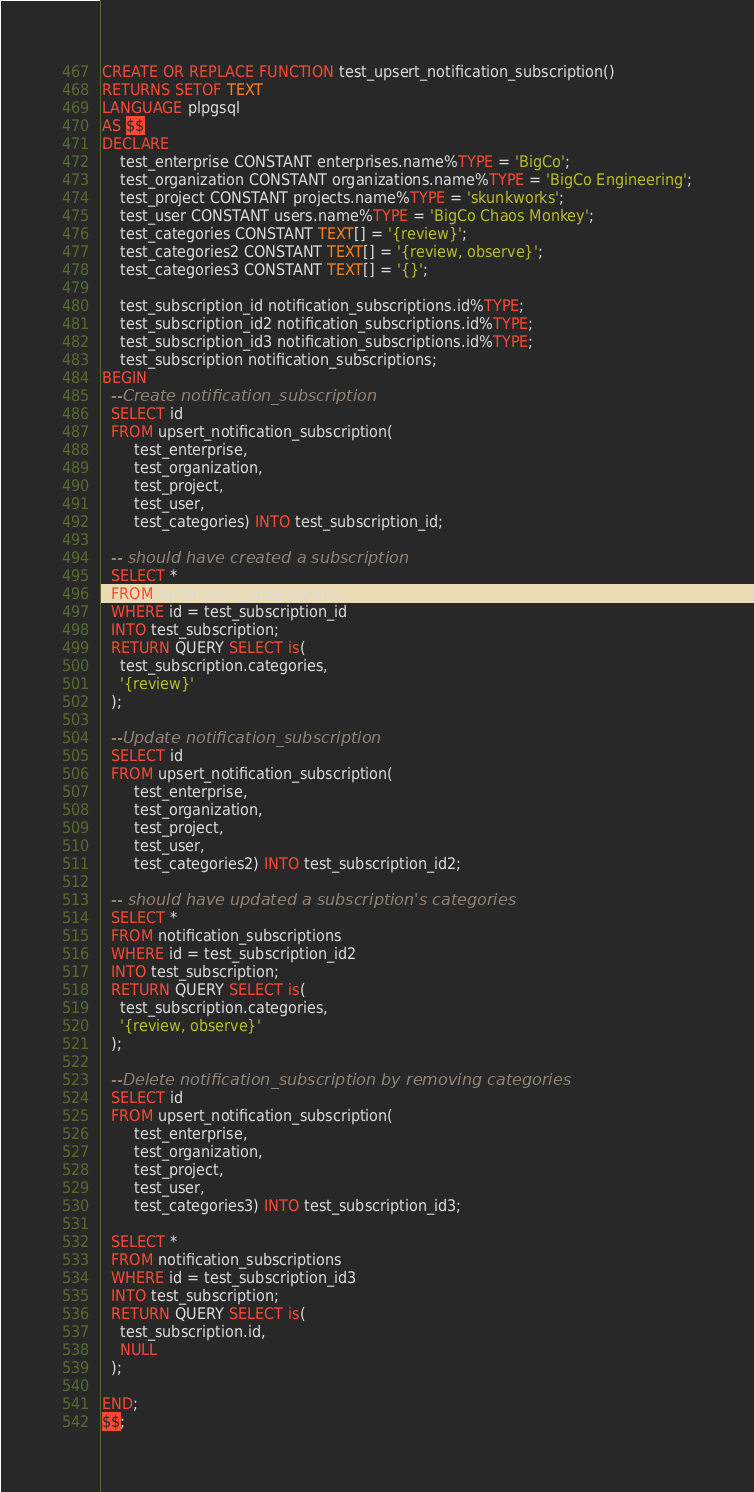Convert code to text. <code><loc_0><loc_0><loc_500><loc_500><_SQL_>CREATE OR REPLACE FUNCTION test_upsert_notification_subscription()
RETURNS SETOF TEXT
LANGUAGE plpgsql
AS $$
DECLARE
    test_enterprise CONSTANT enterprises.name%TYPE = 'BigCo';
    test_organization CONSTANT organizations.name%TYPE = 'BigCo Engineering';
    test_project CONSTANT projects.name%TYPE = 'skunkworks';
    test_user CONSTANT users.name%TYPE = 'BigCo Chaos Monkey';
    test_categories CONSTANT TEXT[] = '{review}';
    test_categories2 CONSTANT TEXT[] = '{review, observe}';
    test_categories3 CONSTANT TEXT[] = '{}';

    test_subscription_id notification_subscriptions.id%TYPE;
    test_subscription_id2 notification_subscriptions.id%TYPE;
    test_subscription_id3 notification_subscriptions.id%TYPE;
    test_subscription notification_subscriptions;
BEGIN
  --Create notification_subscription
  SELECT id
  FROM upsert_notification_subscription(
       test_enterprise,
       test_organization,
       test_project,
       test_user,
       test_categories) INTO test_subscription_id;

  -- should have created a subscription
  SELECT *
  FROM notification_subscriptions
  WHERE id = test_subscription_id
  INTO test_subscription;
  RETURN QUERY SELECT is(
    test_subscription.categories,
    '{review}'
  );

  --Update notification_subscription
  SELECT id
  FROM upsert_notification_subscription(
       test_enterprise,
       test_organization,
       test_project,
       test_user,
       test_categories2) INTO test_subscription_id2;

  -- should have updated a subscription's categories
  SELECT *
  FROM notification_subscriptions
  WHERE id = test_subscription_id2
  INTO test_subscription;
  RETURN QUERY SELECT is(
    test_subscription.categories,
    '{review, observe}'
  );

  --Delete notification_subscription by removing categories
  SELECT id
  FROM upsert_notification_subscription(
       test_enterprise,
       test_organization,
       test_project,
       test_user,
       test_categories3) INTO test_subscription_id3;

  SELECT *
  FROM notification_subscriptions
  WHERE id = test_subscription_id3
  INTO test_subscription;
  RETURN QUERY SELECT is(
    test_subscription.id,
    NULL
  );

END;
$$;

</code> 